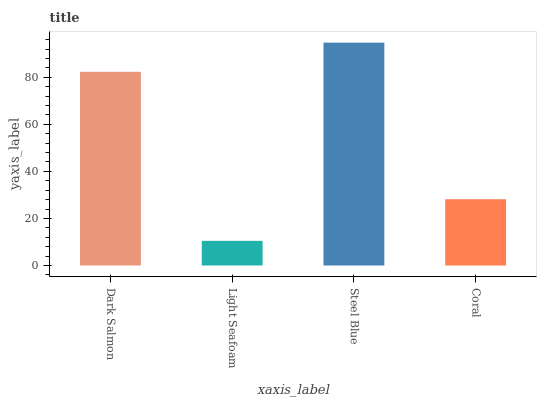Is Light Seafoam the minimum?
Answer yes or no. Yes. Is Steel Blue the maximum?
Answer yes or no. Yes. Is Steel Blue the minimum?
Answer yes or no. No. Is Light Seafoam the maximum?
Answer yes or no. No. Is Steel Blue greater than Light Seafoam?
Answer yes or no. Yes. Is Light Seafoam less than Steel Blue?
Answer yes or no. Yes. Is Light Seafoam greater than Steel Blue?
Answer yes or no. No. Is Steel Blue less than Light Seafoam?
Answer yes or no. No. Is Dark Salmon the high median?
Answer yes or no. Yes. Is Coral the low median?
Answer yes or no. Yes. Is Steel Blue the high median?
Answer yes or no. No. Is Dark Salmon the low median?
Answer yes or no. No. 